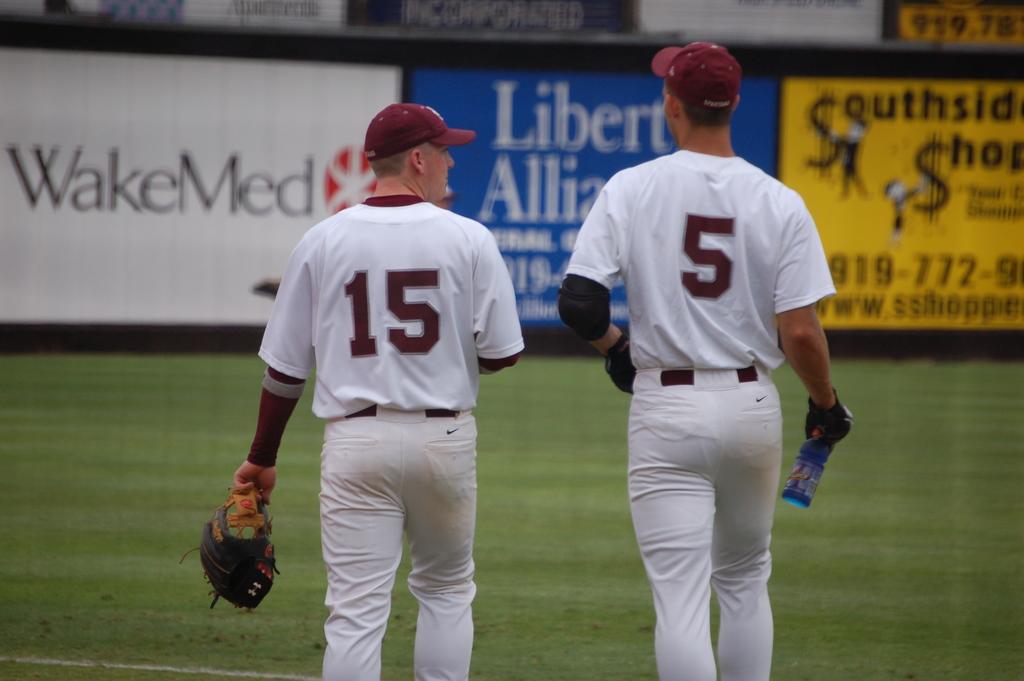What is the name of the company advertising on the billboard on the left?
Make the answer very short. Wakemed. What is the number of the jersey on the left side?
Keep it short and to the point. 15. 